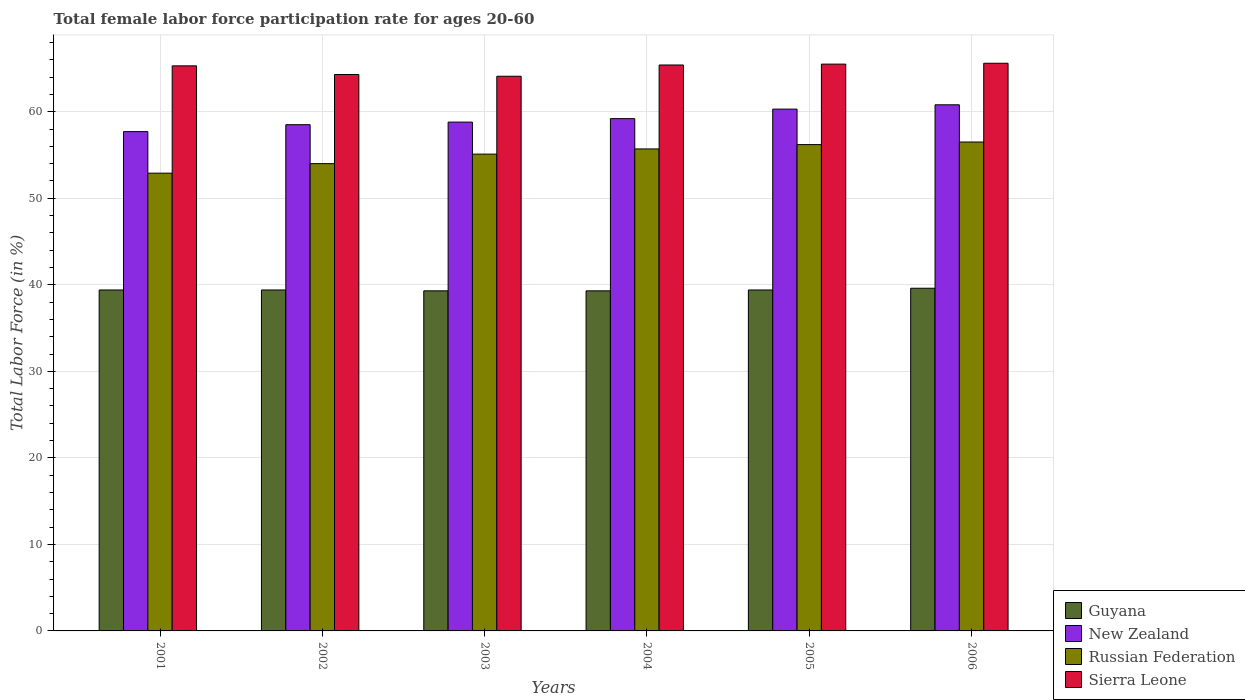How many different coloured bars are there?
Keep it short and to the point. 4. How many groups of bars are there?
Ensure brevity in your answer.  6. Are the number of bars per tick equal to the number of legend labels?
Keep it short and to the point. Yes. Are the number of bars on each tick of the X-axis equal?
Your answer should be compact. Yes. How many bars are there on the 3rd tick from the right?
Provide a short and direct response. 4. What is the label of the 1st group of bars from the left?
Provide a succinct answer. 2001. In how many cases, is the number of bars for a given year not equal to the number of legend labels?
Keep it short and to the point. 0. What is the female labor force participation rate in Sierra Leone in 2002?
Make the answer very short. 64.3. Across all years, what is the maximum female labor force participation rate in Sierra Leone?
Offer a terse response. 65.6. Across all years, what is the minimum female labor force participation rate in New Zealand?
Make the answer very short. 57.7. In which year was the female labor force participation rate in Russian Federation minimum?
Keep it short and to the point. 2001. What is the total female labor force participation rate in Russian Federation in the graph?
Provide a short and direct response. 330.4. What is the difference between the female labor force participation rate in Guyana in 2005 and that in 2006?
Make the answer very short. -0.2. What is the difference between the female labor force participation rate in New Zealand in 2002 and the female labor force participation rate in Sierra Leone in 2004?
Offer a terse response. -6.9. What is the average female labor force participation rate in Sierra Leone per year?
Ensure brevity in your answer.  65.03. In the year 2002, what is the difference between the female labor force participation rate in Russian Federation and female labor force participation rate in Guyana?
Ensure brevity in your answer.  14.6. What is the ratio of the female labor force participation rate in Russian Federation in 2001 to that in 2003?
Your answer should be very brief. 0.96. Is the female labor force participation rate in Russian Federation in 2001 less than that in 2006?
Your answer should be compact. Yes. Is the difference between the female labor force participation rate in Russian Federation in 2005 and 2006 greater than the difference between the female labor force participation rate in Guyana in 2005 and 2006?
Offer a terse response. No. What is the difference between the highest and the second highest female labor force participation rate in Russian Federation?
Offer a very short reply. 0.3. What is the difference between the highest and the lowest female labor force participation rate in Russian Federation?
Make the answer very short. 3.6. Is the sum of the female labor force participation rate in Russian Federation in 2005 and 2006 greater than the maximum female labor force participation rate in Guyana across all years?
Your answer should be compact. Yes. Is it the case that in every year, the sum of the female labor force participation rate in Russian Federation and female labor force participation rate in New Zealand is greater than the sum of female labor force participation rate in Guyana and female labor force participation rate in Sierra Leone?
Offer a terse response. Yes. What does the 4th bar from the left in 2001 represents?
Provide a succinct answer. Sierra Leone. What does the 3rd bar from the right in 2005 represents?
Offer a terse response. New Zealand. How many years are there in the graph?
Your response must be concise. 6. What is the difference between two consecutive major ticks on the Y-axis?
Your response must be concise. 10. Does the graph contain any zero values?
Provide a short and direct response. No. What is the title of the graph?
Your answer should be compact. Total female labor force participation rate for ages 20-60. Does "Madagascar" appear as one of the legend labels in the graph?
Provide a short and direct response. No. What is the label or title of the X-axis?
Offer a terse response. Years. What is the Total Labor Force (in %) of Guyana in 2001?
Your response must be concise. 39.4. What is the Total Labor Force (in %) of New Zealand in 2001?
Keep it short and to the point. 57.7. What is the Total Labor Force (in %) of Russian Federation in 2001?
Offer a terse response. 52.9. What is the Total Labor Force (in %) in Sierra Leone in 2001?
Give a very brief answer. 65.3. What is the Total Labor Force (in %) of Guyana in 2002?
Provide a short and direct response. 39.4. What is the Total Labor Force (in %) of New Zealand in 2002?
Offer a very short reply. 58.5. What is the Total Labor Force (in %) in Russian Federation in 2002?
Your answer should be very brief. 54. What is the Total Labor Force (in %) in Sierra Leone in 2002?
Your answer should be very brief. 64.3. What is the Total Labor Force (in %) of Guyana in 2003?
Offer a very short reply. 39.3. What is the Total Labor Force (in %) of New Zealand in 2003?
Ensure brevity in your answer.  58.8. What is the Total Labor Force (in %) of Russian Federation in 2003?
Your answer should be compact. 55.1. What is the Total Labor Force (in %) in Sierra Leone in 2003?
Make the answer very short. 64.1. What is the Total Labor Force (in %) of Guyana in 2004?
Your response must be concise. 39.3. What is the Total Labor Force (in %) of New Zealand in 2004?
Offer a very short reply. 59.2. What is the Total Labor Force (in %) of Russian Federation in 2004?
Keep it short and to the point. 55.7. What is the Total Labor Force (in %) of Sierra Leone in 2004?
Your response must be concise. 65.4. What is the Total Labor Force (in %) in Guyana in 2005?
Keep it short and to the point. 39.4. What is the Total Labor Force (in %) of New Zealand in 2005?
Provide a short and direct response. 60.3. What is the Total Labor Force (in %) in Russian Federation in 2005?
Provide a succinct answer. 56.2. What is the Total Labor Force (in %) in Sierra Leone in 2005?
Ensure brevity in your answer.  65.5. What is the Total Labor Force (in %) of Guyana in 2006?
Your response must be concise. 39.6. What is the Total Labor Force (in %) of New Zealand in 2006?
Your answer should be very brief. 60.8. What is the Total Labor Force (in %) of Russian Federation in 2006?
Provide a succinct answer. 56.5. What is the Total Labor Force (in %) in Sierra Leone in 2006?
Your response must be concise. 65.6. Across all years, what is the maximum Total Labor Force (in %) in Guyana?
Your answer should be very brief. 39.6. Across all years, what is the maximum Total Labor Force (in %) of New Zealand?
Offer a very short reply. 60.8. Across all years, what is the maximum Total Labor Force (in %) in Russian Federation?
Your answer should be very brief. 56.5. Across all years, what is the maximum Total Labor Force (in %) in Sierra Leone?
Your answer should be very brief. 65.6. Across all years, what is the minimum Total Labor Force (in %) in Guyana?
Provide a short and direct response. 39.3. Across all years, what is the minimum Total Labor Force (in %) in New Zealand?
Your answer should be compact. 57.7. Across all years, what is the minimum Total Labor Force (in %) in Russian Federation?
Ensure brevity in your answer.  52.9. Across all years, what is the minimum Total Labor Force (in %) of Sierra Leone?
Offer a very short reply. 64.1. What is the total Total Labor Force (in %) in Guyana in the graph?
Make the answer very short. 236.4. What is the total Total Labor Force (in %) in New Zealand in the graph?
Give a very brief answer. 355.3. What is the total Total Labor Force (in %) of Russian Federation in the graph?
Your response must be concise. 330.4. What is the total Total Labor Force (in %) in Sierra Leone in the graph?
Your answer should be very brief. 390.2. What is the difference between the Total Labor Force (in %) in New Zealand in 2001 and that in 2002?
Your answer should be compact. -0.8. What is the difference between the Total Labor Force (in %) of Sierra Leone in 2001 and that in 2002?
Keep it short and to the point. 1. What is the difference between the Total Labor Force (in %) in Sierra Leone in 2001 and that in 2003?
Keep it short and to the point. 1.2. What is the difference between the Total Labor Force (in %) of Guyana in 2001 and that in 2004?
Make the answer very short. 0.1. What is the difference between the Total Labor Force (in %) in New Zealand in 2001 and that in 2004?
Keep it short and to the point. -1.5. What is the difference between the Total Labor Force (in %) in Russian Federation in 2001 and that in 2004?
Your response must be concise. -2.8. What is the difference between the Total Labor Force (in %) in Russian Federation in 2001 and that in 2005?
Ensure brevity in your answer.  -3.3. What is the difference between the Total Labor Force (in %) of Sierra Leone in 2001 and that in 2005?
Your response must be concise. -0.2. What is the difference between the Total Labor Force (in %) in New Zealand in 2001 and that in 2006?
Give a very brief answer. -3.1. What is the difference between the Total Labor Force (in %) in Guyana in 2002 and that in 2004?
Provide a succinct answer. 0.1. What is the difference between the Total Labor Force (in %) of New Zealand in 2002 and that in 2004?
Make the answer very short. -0.7. What is the difference between the Total Labor Force (in %) in New Zealand in 2002 and that in 2005?
Your answer should be very brief. -1.8. What is the difference between the Total Labor Force (in %) in Sierra Leone in 2002 and that in 2005?
Provide a succinct answer. -1.2. What is the difference between the Total Labor Force (in %) of Guyana in 2002 and that in 2006?
Your response must be concise. -0.2. What is the difference between the Total Labor Force (in %) in New Zealand in 2002 and that in 2006?
Offer a terse response. -2.3. What is the difference between the Total Labor Force (in %) of Russian Federation in 2002 and that in 2006?
Keep it short and to the point. -2.5. What is the difference between the Total Labor Force (in %) in Guyana in 2003 and that in 2004?
Ensure brevity in your answer.  0. What is the difference between the Total Labor Force (in %) in New Zealand in 2003 and that in 2004?
Your answer should be compact. -0.4. What is the difference between the Total Labor Force (in %) of Guyana in 2003 and that in 2005?
Ensure brevity in your answer.  -0.1. What is the difference between the Total Labor Force (in %) in Sierra Leone in 2003 and that in 2005?
Give a very brief answer. -1.4. What is the difference between the Total Labor Force (in %) in Guyana in 2003 and that in 2006?
Your answer should be very brief. -0.3. What is the difference between the Total Labor Force (in %) of Russian Federation in 2003 and that in 2006?
Provide a short and direct response. -1.4. What is the difference between the Total Labor Force (in %) in Russian Federation in 2004 and that in 2005?
Your answer should be compact. -0.5. What is the difference between the Total Labor Force (in %) of Guyana in 2004 and that in 2006?
Keep it short and to the point. -0.3. What is the difference between the Total Labor Force (in %) in Sierra Leone in 2004 and that in 2006?
Offer a very short reply. -0.2. What is the difference between the Total Labor Force (in %) in New Zealand in 2005 and that in 2006?
Ensure brevity in your answer.  -0.5. What is the difference between the Total Labor Force (in %) in Guyana in 2001 and the Total Labor Force (in %) in New Zealand in 2002?
Ensure brevity in your answer.  -19.1. What is the difference between the Total Labor Force (in %) in Guyana in 2001 and the Total Labor Force (in %) in Russian Federation in 2002?
Make the answer very short. -14.6. What is the difference between the Total Labor Force (in %) in Guyana in 2001 and the Total Labor Force (in %) in Sierra Leone in 2002?
Make the answer very short. -24.9. What is the difference between the Total Labor Force (in %) of New Zealand in 2001 and the Total Labor Force (in %) of Sierra Leone in 2002?
Ensure brevity in your answer.  -6.6. What is the difference between the Total Labor Force (in %) of Russian Federation in 2001 and the Total Labor Force (in %) of Sierra Leone in 2002?
Provide a short and direct response. -11.4. What is the difference between the Total Labor Force (in %) of Guyana in 2001 and the Total Labor Force (in %) of New Zealand in 2003?
Offer a very short reply. -19.4. What is the difference between the Total Labor Force (in %) of Guyana in 2001 and the Total Labor Force (in %) of Russian Federation in 2003?
Your answer should be compact. -15.7. What is the difference between the Total Labor Force (in %) in Guyana in 2001 and the Total Labor Force (in %) in Sierra Leone in 2003?
Provide a succinct answer. -24.7. What is the difference between the Total Labor Force (in %) of New Zealand in 2001 and the Total Labor Force (in %) of Sierra Leone in 2003?
Your answer should be compact. -6.4. What is the difference between the Total Labor Force (in %) in Russian Federation in 2001 and the Total Labor Force (in %) in Sierra Leone in 2003?
Provide a short and direct response. -11.2. What is the difference between the Total Labor Force (in %) in Guyana in 2001 and the Total Labor Force (in %) in New Zealand in 2004?
Offer a very short reply. -19.8. What is the difference between the Total Labor Force (in %) of Guyana in 2001 and the Total Labor Force (in %) of Russian Federation in 2004?
Provide a short and direct response. -16.3. What is the difference between the Total Labor Force (in %) in Guyana in 2001 and the Total Labor Force (in %) in Sierra Leone in 2004?
Ensure brevity in your answer.  -26. What is the difference between the Total Labor Force (in %) in Guyana in 2001 and the Total Labor Force (in %) in New Zealand in 2005?
Offer a very short reply. -20.9. What is the difference between the Total Labor Force (in %) of Guyana in 2001 and the Total Labor Force (in %) of Russian Federation in 2005?
Provide a short and direct response. -16.8. What is the difference between the Total Labor Force (in %) of Guyana in 2001 and the Total Labor Force (in %) of Sierra Leone in 2005?
Offer a very short reply. -26.1. What is the difference between the Total Labor Force (in %) in Russian Federation in 2001 and the Total Labor Force (in %) in Sierra Leone in 2005?
Give a very brief answer. -12.6. What is the difference between the Total Labor Force (in %) in Guyana in 2001 and the Total Labor Force (in %) in New Zealand in 2006?
Give a very brief answer. -21.4. What is the difference between the Total Labor Force (in %) in Guyana in 2001 and the Total Labor Force (in %) in Russian Federation in 2006?
Your response must be concise. -17.1. What is the difference between the Total Labor Force (in %) of Guyana in 2001 and the Total Labor Force (in %) of Sierra Leone in 2006?
Offer a very short reply. -26.2. What is the difference between the Total Labor Force (in %) in New Zealand in 2001 and the Total Labor Force (in %) in Russian Federation in 2006?
Offer a terse response. 1.2. What is the difference between the Total Labor Force (in %) of New Zealand in 2001 and the Total Labor Force (in %) of Sierra Leone in 2006?
Give a very brief answer. -7.9. What is the difference between the Total Labor Force (in %) in Guyana in 2002 and the Total Labor Force (in %) in New Zealand in 2003?
Offer a very short reply. -19.4. What is the difference between the Total Labor Force (in %) in Guyana in 2002 and the Total Labor Force (in %) in Russian Federation in 2003?
Provide a succinct answer. -15.7. What is the difference between the Total Labor Force (in %) in Guyana in 2002 and the Total Labor Force (in %) in Sierra Leone in 2003?
Provide a short and direct response. -24.7. What is the difference between the Total Labor Force (in %) in Russian Federation in 2002 and the Total Labor Force (in %) in Sierra Leone in 2003?
Provide a succinct answer. -10.1. What is the difference between the Total Labor Force (in %) in Guyana in 2002 and the Total Labor Force (in %) in New Zealand in 2004?
Give a very brief answer. -19.8. What is the difference between the Total Labor Force (in %) in Guyana in 2002 and the Total Labor Force (in %) in Russian Federation in 2004?
Provide a succinct answer. -16.3. What is the difference between the Total Labor Force (in %) of New Zealand in 2002 and the Total Labor Force (in %) of Sierra Leone in 2004?
Give a very brief answer. -6.9. What is the difference between the Total Labor Force (in %) in Guyana in 2002 and the Total Labor Force (in %) in New Zealand in 2005?
Your response must be concise. -20.9. What is the difference between the Total Labor Force (in %) in Guyana in 2002 and the Total Labor Force (in %) in Russian Federation in 2005?
Make the answer very short. -16.8. What is the difference between the Total Labor Force (in %) in Guyana in 2002 and the Total Labor Force (in %) in Sierra Leone in 2005?
Offer a very short reply. -26.1. What is the difference between the Total Labor Force (in %) of Russian Federation in 2002 and the Total Labor Force (in %) of Sierra Leone in 2005?
Provide a short and direct response. -11.5. What is the difference between the Total Labor Force (in %) of Guyana in 2002 and the Total Labor Force (in %) of New Zealand in 2006?
Provide a short and direct response. -21.4. What is the difference between the Total Labor Force (in %) in Guyana in 2002 and the Total Labor Force (in %) in Russian Federation in 2006?
Keep it short and to the point. -17.1. What is the difference between the Total Labor Force (in %) of Guyana in 2002 and the Total Labor Force (in %) of Sierra Leone in 2006?
Offer a very short reply. -26.2. What is the difference between the Total Labor Force (in %) in New Zealand in 2002 and the Total Labor Force (in %) in Sierra Leone in 2006?
Your answer should be compact. -7.1. What is the difference between the Total Labor Force (in %) of Russian Federation in 2002 and the Total Labor Force (in %) of Sierra Leone in 2006?
Give a very brief answer. -11.6. What is the difference between the Total Labor Force (in %) of Guyana in 2003 and the Total Labor Force (in %) of New Zealand in 2004?
Offer a terse response. -19.9. What is the difference between the Total Labor Force (in %) in Guyana in 2003 and the Total Labor Force (in %) in Russian Federation in 2004?
Provide a succinct answer. -16.4. What is the difference between the Total Labor Force (in %) of Guyana in 2003 and the Total Labor Force (in %) of Sierra Leone in 2004?
Provide a succinct answer. -26.1. What is the difference between the Total Labor Force (in %) of New Zealand in 2003 and the Total Labor Force (in %) of Russian Federation in 2004?
Provide a succinct answer. 3.1. What is the difference between the Total Labor Force (in %) in New Zealand in 2003 and the Total Labor Force (in %) in Sierra Leone in 2004?
Give a very brief answer. -6.6. What is the difference between the Total Labor Force (in %) of Russian Federation in 2003 and the Total Labor Force (in %) of Sierra Leone in 2004?
Your answer should be compact. -10.3. What is the difference between the Total Labor Force (in %) of Guyana in 2003 and the Total Labor Force (in %) of New Zealand in 2005?
Keep it short and to the point. -21. What is the difference between the Total Labor Force (in %) of Guyana in 2003 and the Total Labor Force (in %) of Russian Federation in 2005?
Offer a very short reply. -16.9. What is the difference between the Total Labor Force (in %) of Guyana in 2003 and the Total Labor Force (in %) of Sierra Leone in 2005?
Your answer should be very brief. -26.2. What is the difference between the Total Labor Force (in %) in Guyana in 2003 and the Total Labor Force (in %) in New Zealand in 2006?
Give a very brief answer. -21.5. What is the difference between the Total Labor Force (in %) in Guyana in 2003 and the Total Labor Force (in %) in Russian Federation in 2006?
Ensure brevity in your answer.  -17.2. What is the difference between the Total Labor Force (in %) in Guyana in 2003 and the Total Labor Force (in %) in Sierra Leone in 2006?
Make the answer very short. -26.3. What is the difference between the Total Labor Force (in %) of New Zealand in 2003 and the Total Labor Force (in %) of Sierra Leone in 2006?
Your answer should be compact. -6.8. What is the difference between the Total Labor Force (in %) of Guyana in 2004 and the Total Labor Force (in %) of New Zealand in 2005?
Keep it short and to the point. -21. What is the difference between the Total Labor Force (in %) of Guyana in 2004 and the Total Labor Force (in %) of Russian Federation in 2005?
Your answer should be compact. -16.9. What is the difference between the Total Labor Force (in %) of Guyana in 2004 and the Total Labor Force (in %) of Sierra Leone in 2005?
Ensure brevity in your answer.  -26.2. What is the difference between the Total Labor Force (in %) in Guyana in 2004 and the Total Labor Force (in %) in New Zealand in 2006?
Offer a very short reply. -21.5. What is the difference between the Total Labor Force (in %) of Guyana in 2004 and the Total Labor Force (in %) of Russian Federation in 2006?
Your answer should be compact. -17.2. What is the difference between the Total Labor Force (in %) in Guyana in 2004 and the Total Labor Force (in %) in Sierra Leone in 2006?
Keep it short and to the point. -26.3. What is the difference between the Total Labor Force (in %) in New Zealand in 2004 and the Total Labor Force (in %) in Sierra Leone in 2006?
Keep it short and to the point. -6.4. What is the difference between the Total Labor Force (in %) in Russian Federation in 2004 and the Total Labor Force (in %) in Sierra Leone in 2006?
Provide a short and direct response. -9.9. What is the difference between the Total Labor Force (in %) of Guyana in 2005 and the Total Labor Force (in %) of New Zealand in 2006?
Ensure brevity in your answer.  -21.4. What is the difference between the Total Labor Force (in %) of Guyana in 2005 and the Total Labor Force (in %) of Russian Federation in 2006?
Make the answer very short. -17.1. What is the difference between the Total Labor Force (in %) in Guyana in 2005 and the Total Labor Force (in %) in Sierra Leone in 2006?
Your answer should be compact. -26.2. What is the difference between the Total Labor Force (in %) in Russian Federation in 2005 and the Total Labor Force (in %) in Sierra Leone in 2006?
Offer a very short reply. -9.4. What is the average Total Labor Force (in %) of Guyana per year?
Provide a succinct answer. 39.4. What is the average Total Labor Force (in %) in New Zealand per year?
Your response must be concise. 59.22. What is the average Total Labor Force (in %) of Russian Federation per year?
Offer a terse response. 55.07. What is the average Total Labor Force (in %) in Sierra Leone per year?
Your answer should be compact. 65.03. In the year 2001, what is the difference between the Total Labor Force (in %) of Guyana and Total Labor Force (in %) of New Zealand?
Your response must be concise. -18.3. In the year 2001, what is the difference between the Total Labor Force (in %) of Guyana and Total Labor Force (in %) of Russian Federation?
Your response must be concise. -13.5. In the year 2001, what is the difference between the Total Labor Force (in %) of Guyana and Total Labor Force (in %) of Sierra Leone?
Your answer should be very brief. -25.9. In the year 2002, what is the difference between the Total Labor Force (in %) in Guyana and Total Labor Force (in %) in New Zealand?
Offer a very short reply. -19.1. In the year 2002, what is the difference between the Total Labor Force (in %) of Guyana and Total Labor Force (in %) of Russian Federation?
Offer a very short reply. -14.6. In the year 2002, what is the difference between the Total Labor Force (in %) of Guyana and Total Labor Force (in %) of Sierra Leone?
Ensure brevity in your answer.  -24.9. In the year 2003, what is the difference between the Total Labor Force (in %) in Guyana and Total Labor Force (in %) in New Zealand?
Provide a succinct answer. -19.5. In the year 2003, what is the difference between the Total Labor Force (in %) of Guyana and Total Labor Force (in %) of Russian Federation?
Offer a very short reply. -15.8. In the year 2003, what is the difference between the Total Labor Force (in %) of Guyana and Total Labor Force (in %) of Sierra Leone?
Provide a short and direct response. -24.8. In the year 2003, what is the difference between the Total Labor Force (in %) in New Zealand and Total Labor Force (in %) in Sierra Leone?
Your answer should be very brief. -5.3. In the year 2004, what is the difference between the Total Labor Force (in %) in Guyana and Total Labor Force (in %) in New Zealand?
Make the answer very short. -19.9. In the year 2004, what is the difference between the Total Labor Force (in %) of Guyana and Total Labor Force (in %) of Russian Federation?
Keep it short and to the point. -16.4. In the year 2004, what is the difference between the Total Labor Force (in %) in Guyana and Total Labor Force (in %) in Sierra Leone?
Ensure brevity in your answer.  -26.1. In the year 2004, what is the difference between the Total Labor Force (in %) of Russian Federation and Total Labor Force (in %) of Sierra Leone?
Your answer should be very brief. -9.7. In the year 2005, what is the difference between the Total Labor Force (in %) in Guyana and Total Labor Force (in %) in New Zealand?
Ensure brevity in your answer.  -20.9. In the year 2005, what is the difference between the Total Labor Force (in %) of Guyana and Total Labor Force (in %) of Russian Federation?
Give a very brief answer. -16.8. In the year 2005, what is the difference between the Total Labor Force (in %) in Guyana and Total Labor Force (in %) in Sierra Leone?
Your response must be concise. -26.1. In the year 2005, what is the difference between the Total Labor Force (in %) in New Zealand and Total Labor Force (in %) in Russian Federation?
Your answer should be compact. 4.1. In the year 2005, what is the difference between the Total Labor Force (in %) in New Zealand and Total Labor Force (in %) in Sierra Leone?
Provide a short and direct response. -5.2. In the year 2005, what is the difference between the Total Labor Force (in %) in Russian Federation and Total Labor Force (in %) in Sierra Leone?
Offer a terse response. -9.3. In the year 2006, what is the difference between the Total Labor Force (in %) in Guyana and Total Labor Force (in %) in New Zealand?
Make the answer very short. -21.2. In the year 2006, what is the difference between the Total Labor Force (in %) in Guyana and Total Labor Force (in %) in Russian Federation?
Provide a succinct answer. -16.9. In the year 2006, what is the difference between the Total Labor Force (in %) in Guyana and Total Labor Force (in %) in Sierra Leone?
Provide a succinct answer. -26. In the year 2006, what is the difference between the Total Labor Force (in %) of New Zealand and Total Labor Force (in %) of Russian Federation?
Your answer should be very brief. 4.3. In the year 2006, what is the difference between the Total Labor Force (in %) in New Zealand and Total Labor Force (in %) in Sierra Leone?
Provide a short and direct response. -4.8. What is the ratio of the Total Labor Force (in %) in Guyana in 2001 to that in 2002?
Your answer should be compact. 1. What is the ratio of the Total Labor Force (in %) of New Zealand in 2001 to that in 2002?
Offer a very short reply. 0.99. What is the ratio of the Total Labor Force (in %) of Russian Federation in 2001 to that in 2002?
Provide a succinct answer. 0.98. What is the ratio of the Total Labor Force (in %) of Sierra Leone in 2001 to that in 2002?
Your answer should be very brief. 1.02. What is the ratio of the Total Labor Force (in %) of Guyana in 2001 to that in 2003?
Give a very brief answer. 1. What is the ratio of the Total Labor Force (in %) in New Zealand in 2001 to that in 2003?
Offer a very short reply. 0.98. What is the ratio of the Total Labor Force (in %) of Russian Federation in 2001 to that in 2003?
Offer a terse response. 0.96. What is the ratio of the Total Labor Force (in %) in Sierra Leone in 2001 to that in 2003?
Provide a short and direct response. 1.02. What is the ratio of the Total Labor Force (in %) of New Zealand in 2001 to that in 2004?
Offer a terse response. 0.97. What is the ratio of the Total Labor Force (in %) of Russian Federation in 2001 to that in 2004?
Your response must be concise. 0.95. What is the ratio of the Total Labor Force (in %) in Guyana in 2001 to that in 2005?
Keep it short and to the point. 1. What is the ratio of the Total Labor Force (in %) of New Zealand in 2001 to that in 2005?
Keep it short and to the point. 0.96. What is the ratio of the Total Labor Force (in %) in Russian Federation in 2001 to that in 2005?
Offer a terse response. 0.94. What is the ratio of the Total Labor Force (in %) of Sierra Leone in 2001 to that in 2005?
Keep it short and to the point. 1. What is the ratio of the Total Labor Force (in %) in Guyana in 2001 to that in 2006?
Your response must be concise. 0.99. What is the ratio of the Total Labor Force (in %) of New Zealand in 2001 to that in 2006?
Provide a succinct answer. 0.95. What is the ratio of the Total Labor Force (in %) in Russian Federation in 2001 to that in 2006?
Your answer should be very brief. 0.94. What is the ratio of the Total Labor Force (in %) of Sierra Leone in 2001 to that in 2006?
Offer a terse response. 1. What is the ratio of the Total Labor Force (in %) in Russian Federation in 2002 to that in 2003?
Your answer should be very brief. 0.98. What is the ratio of the Total Labor Force (in %) of Sierra Leone in 2002 to that in 2003?
Provide a succinct answer. 1. What is the ratio of the Total Labor Force (in %) of New Zealand in 2002 to that in 2004?
Offer a very short reply. 0.99. What is the ratio of the Total Labor Force (in %) in Russian Federation in 2002 to that in 2004?
Provide a succinct answer. 0.97. What is the ratio of the Total Labor Force (in %) in Sierra Leone in 2002 to that in 2004?
Provide a short and direct response. 0.98. What is the ratio of the Total Labor Force (in %) of New Zealand in 2002 to that in 2005?
Offer a terse response. 0.97. What is the ratio of the Total Labor Force (in %) in Russian Federation in 2002 to that in 2005?
Offer a terse response. 0.96. What is the ratio of the Total Labor Force (in %) in Sierra Leone in 2002 to that in 2005?
Offer a very short reply. 0.98. What is the ratio of the Total Labor Force (in %) of Guyana in 2002 to that in 2006?
Offer a very short reply. 0.99. What is the ratio of the Total Labor Force (in %) in New Zealand in 2002 to that in 2006?
Provide a succinct answer. 0.96. What is the ratio of the Total Labor Force (in %) in Russian Federation in 2002 to that in 2006?
Provide a succinct answer. 0.96. What is the ratio of the Total Labor Force (in %) in Sierra Leone in 2002 to that in 2006?
Ensure brevity in your answer.  0.98. What is the ratio of the Total Labor Force (in %) in New Zealand in 2003 to that in 2004?
Offer a terse response. 0.99. What is the ratio of the Total Labor Force (in %) of Sierra Leone in 2003 to that in 2004?
Your answer should be very brief. 0.98. What is the ratio of the Total Labor Force (in %) in New Zealand in 2003 to that in 2005?
Keep it short and to the point. 0.98. What is the ratio of the Total Labor Force (in %) in Russian Federation in 2003 to that in 2005?
Your answer should be compact. 0.98. What is the ratio of the Total Labor Force (in %) in Sierra Leone in 2003 to that in 2005?
Ensure brevity in your answer.  0.98. What is the ratio of the Total Labor Force (in %) of New Zealand in 2003 to that in 2006?
Keep it short and to the point. 0.97. What is the ratio of the Total Labor Force (in %) of Russian Federation in 2003 to that in 2006?
Make the answer very short. 0.98. What is the ratio of the Total Labor Force (in %) of Sierra Leone in 2003 to that in 2006?
Give a very brief answer. 0.98. What is the ratio of the Total Labor Force (in %) in Guyana in 2004 to that in 2005?
Provide a short and direct response. 1. What is the ratio of the Total Labor Force (in %) in New Zealand in 2004 to that in 2005?
Your response must be concise. 0.98. What is the ratio of the Total Labor Force (in %) of Sierra Leone in 2004 to that in 2005?
Your answer should be very brief. 1. What is the ratio of the Total Labor Force (in %) in Guyana in 2004 to that in 2006?
Offer a very short reply. 0.99. What is the ratio of the Total Labor Force (in %) in New Zealand in 2004 to that in 2006?
Keep it short and to the point. 0.97. What is the ratio of the Total Labor Force (in %) of Russian Federation in 2004 to that in 2006?
Offer a very short reply. 0.99. What is the ratio of the Total Labor Force (in %) of Sierra Leone in 2004 to that in 2006?
Your answer should be very brief. 1. What is the ratio of the Total Labor Force (in %) in Russian Federation in 2005 to that in 2006?
Offer a terse response. 0.99. What is the ratio of the Total Labor Force (in %) in Sierra Leone in 2005 to that in 2006?
Ensure brevity in your answer.  1. What is the difference between the highest and the second highest Total Labor Force (in %) in New Zealand?
Give a very brief answer. 0.5. What is the difference between the highest and the lowest Total Labor Force (in %) in Guyana?
Ensure brevity in your answer.  0.3. What is the difference between the highest and the lowest Total Labor Force (in %) of Sierra Leone?
Offer a very short reply. 1.5. 